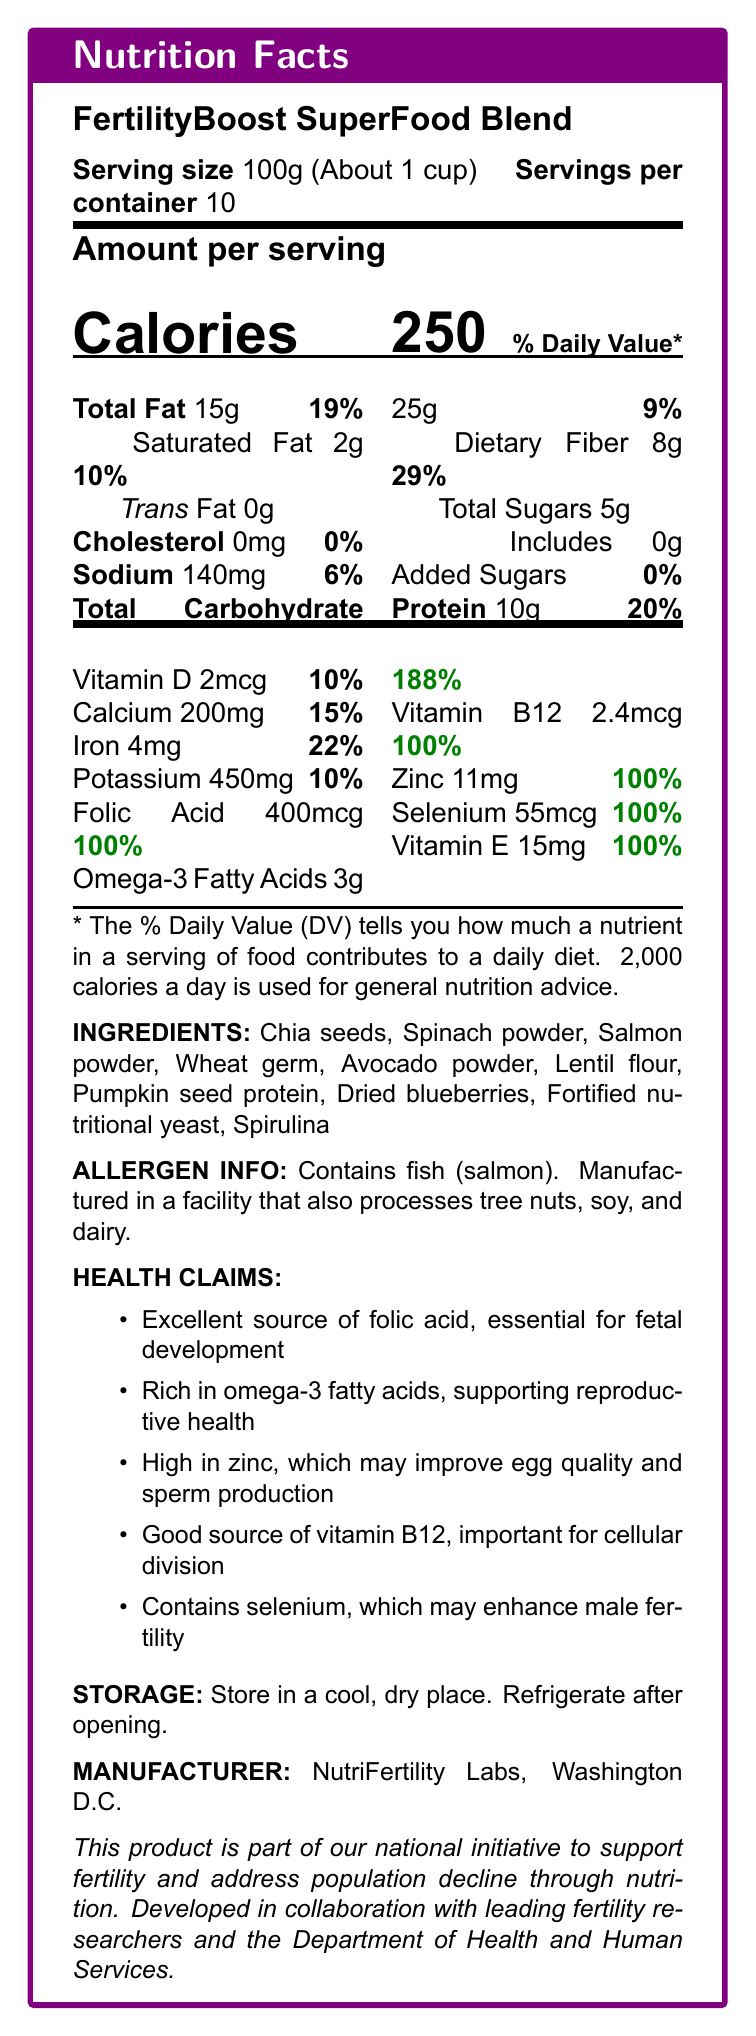What is the serving size of FertilityBoost SuperFood Blend? The serving size is specified at the beginning of the document.
Answer: 100g How many servings are there per container? The document states that there are 10 servings per container.
Answer: 10 How many grams of total fat are there per serving? The amount of total fat per serving is listed as 15g.
Answer: 15g What is the percentage of daily value of saturated fat provided by one serving? The daily value percentage of saturated fat per serving is denoted as 10%.
Answer: 10% What vitamin is present in a quantity of 2.4mcg per serving? The document lists vitamin B12 as containing 2.4mcg per serving.
Answer: Vitamin B12 Which ingredient can be a potential allergen? A. Chia seeds B. Salmon powder C. Lentil flour D. Dried blueberries The allergen information specifies that the product contains fish (salmon).
Answer: B. Salmon powder What nutrient in the FertilityBoost SuperFood Blend has a daily value percentage of 188% per serving? A. Folic acid B. Omega-3 fatty acids C. Vitamin D D. Zinc Omega-3 fatty acids have a daily value percentage of 188% per serving.
Answer: B. Omega-3 fatty acids Does the FertilityBoost SuperFood Blend contain any trans fat? The document specifies that there is 0g of trans fat per serving.
Answer: No Summarize the main purpose of the FertilityBoost SuperFood Blend as stated in the document. The document highlights that the blend is designed to support fertility and is developed in collaboration with fertility researchers and the Department of Health and Human Services.
Answer: The product aims to support fertility and address population decline through nutrition by providing essential nutrients such as folic acid, omega-3 fatty acids, zinc, and others. Can we deduce the exact amount of Vitamin C in this product from the document? The document doesn't provide any information about the amount of Vitamin C in FertilityBoost SuperFood Blend.
Answer: Not enough information 